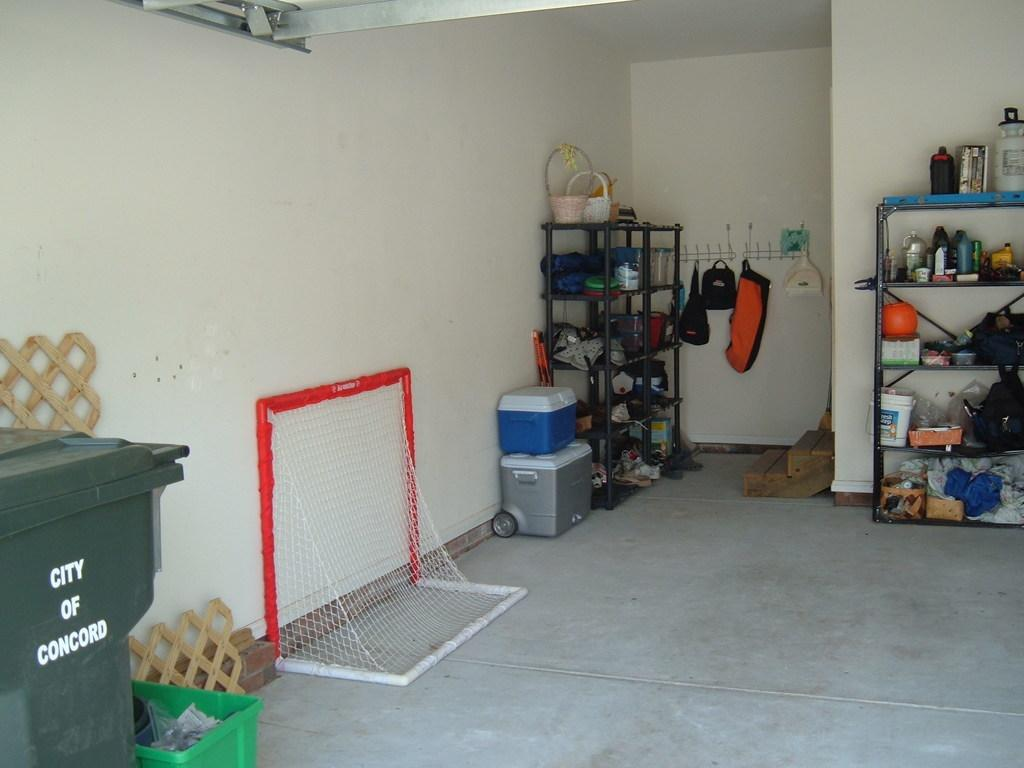<image>
Offer a succinct explanation of the picture presented. a trash can in a garage that says City of Concord 